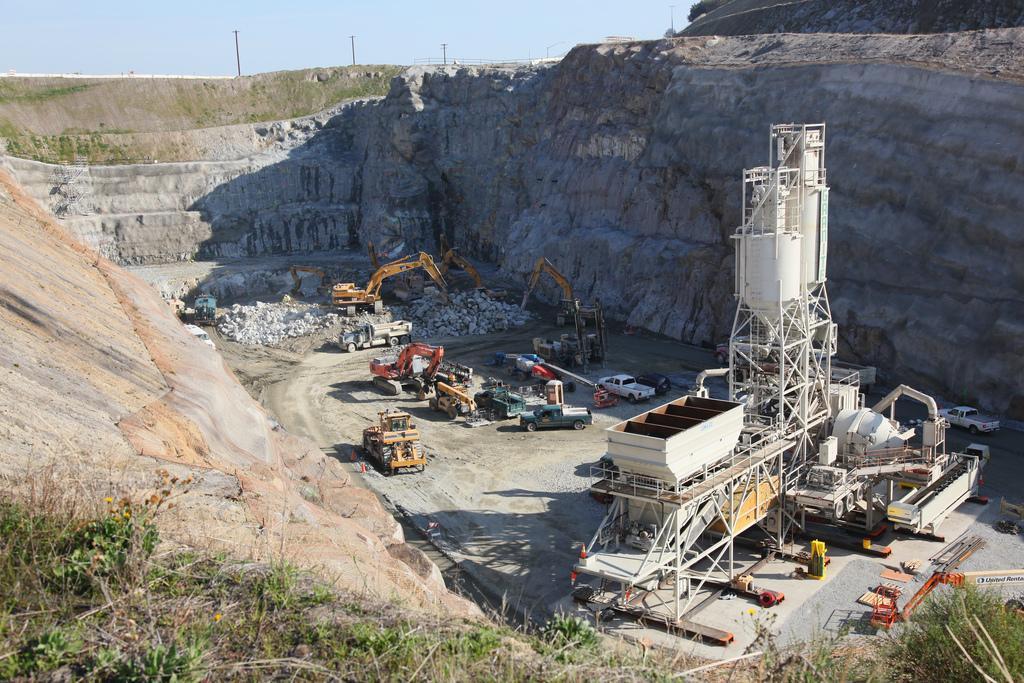In one or two sentences, can you explain what this image depicts? In this image, we can see the ground. We can see some vehicles and rocks. We can also see a white colored object. We can see some hills on the left and right. We can see some grass. There are a few poles. We can see the sky. 